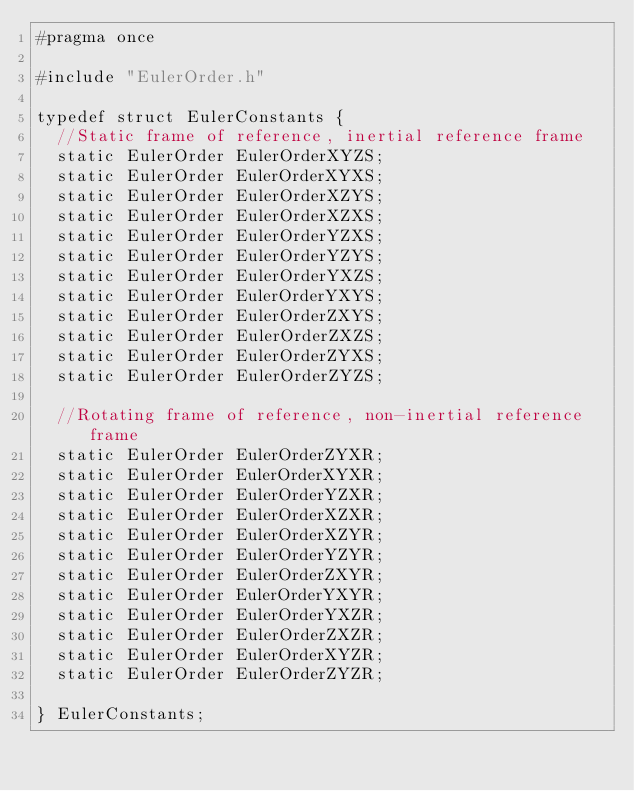Convert code to text. <code><loc_0><loc_0><loc_500><loc_500><_C_>#pragma once

#include "EulerOrder.h"

typedef struct EulerConstants {
	//Static frame of reference, inertial reference frame
	static EulerOrder EulerOrderXYZS;
	static EulerOrder EulerOrderXYXS;
	static EulerOrder EulerOrderXZYS;
	static EulerOrder EulerOrderXZXS;
	static EulerOrder EulerOrderYZXS;
	static EulerOrder EulerOrderYZYS;
	static EulerOrder EulerOrderYXZS;
	static EulerOrder EulerOrderYXYS;
	static EulerOrder EulerOrderZXYS;
	static EulerOrder EulerOrderZXZS;
	static EulerOrder EulerOrderZYXS;
	static EulerOrder EulerOrderZYZS;

	//Rotating frame of reference, non-inertial reference frame
	static EulerOrder EulerOrderZYXR;
	static EulerOrder EulerOrderXYXR;
	static EulerOrder EulerOrderYZXR;
	static EulerOrder EulerOrderXZXR;
	static EulerOrder EulerOrderXZYR;
	static EulerOrder EulerOrderYZYR;
	static EulerOrder EulerOrderZXYR;
	static EulerOrder EulerOrderYXYR;
	static EulerOrder EulerOrderYXZR;
	static EulerOrder EulerOrderZXZR;
	static EulerOrder EulerOrderXYZR;
	static EulerOrder EulerOrderZYZR;

} EulerConstants;</code> 